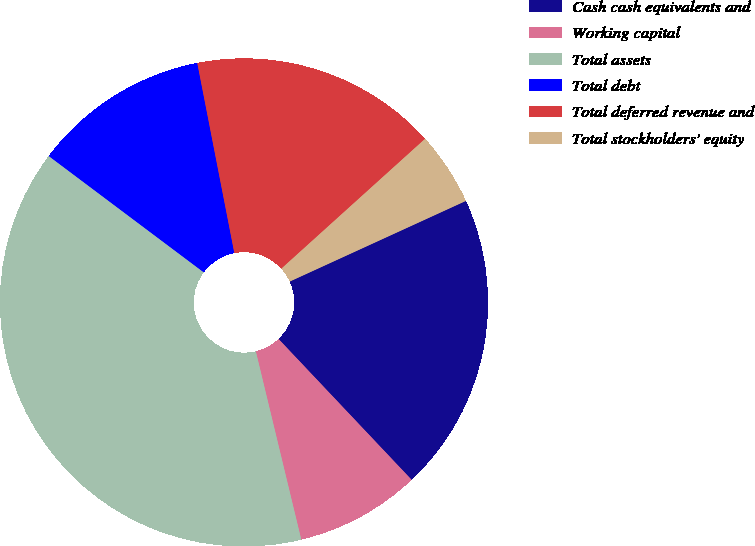Convert chart to OTSL. <chart><loc_0><loc_0><loc_500><loc_500><pie_chart><fcel>Cash cash equivalents and<fcel>Working capital<fcel>Total assets<fcel>Total debt<fcel>Total deferred revenue and<fcel>Total stockholders' equity<nl><fcel>19.78%<fcel>8.28%<fcel>39.01%<fcel>11.69%<fcel>16.37%<fcel>4.86%<nl></chart> 